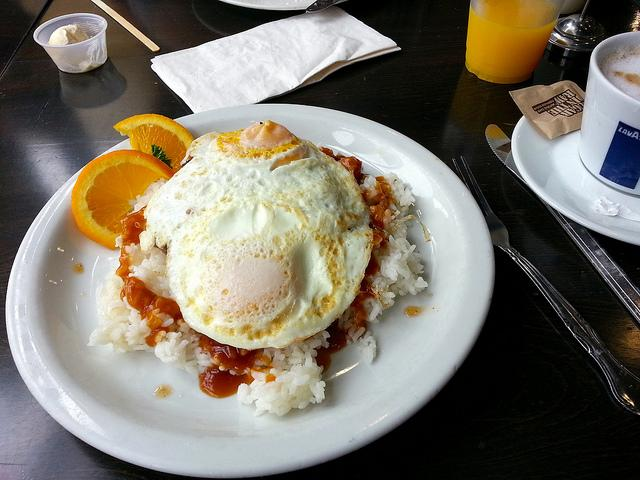What is in the tall glass on the right hand side? Please explain your reasoning. orange juice. The tall glass behind the plate of breakfast contains bright orange juice. 